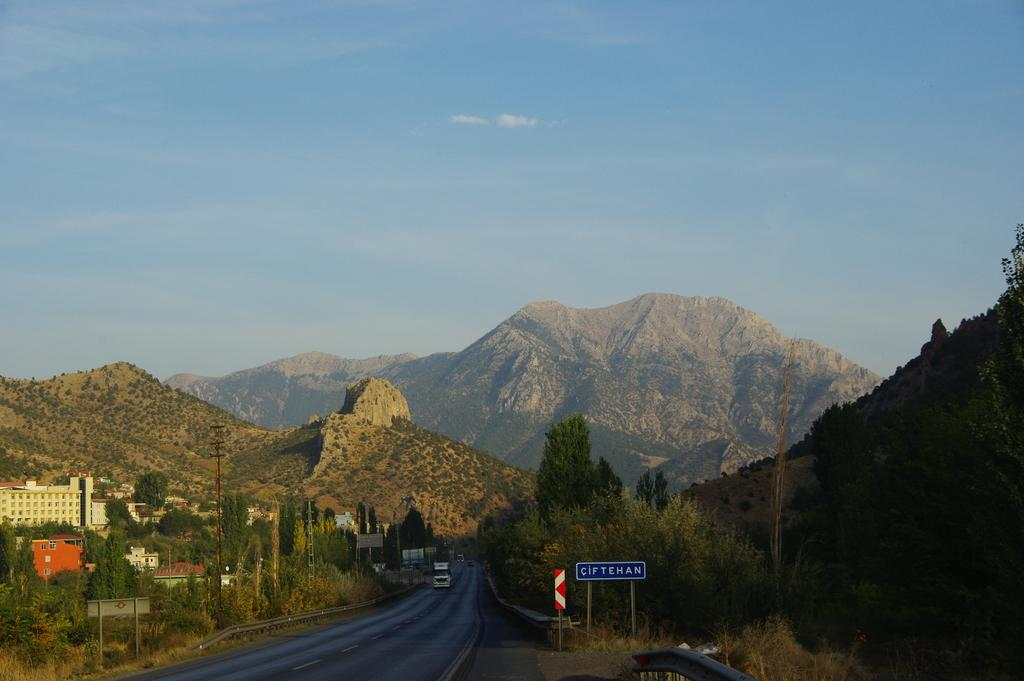What is on the road in the image? There is a vehicle on the road in the image. What type of surface is visible in the image? There is a road in the image. What object can be seen standing vertically in the image? There is an electric pole in the image. What geographical feature is visible in the image? There is a mountain in the image. What is the color of the sky in the image? The sky is pale blue in color. What type of structures are present in the image? There are buildings in the image. What type of silk is being used for the activity in the image? There is no silk or activity involving silk present in the image. What type of joke can be seen on the board in the image? There is no joke present on the board in the image; it may contain information or advertisements. 